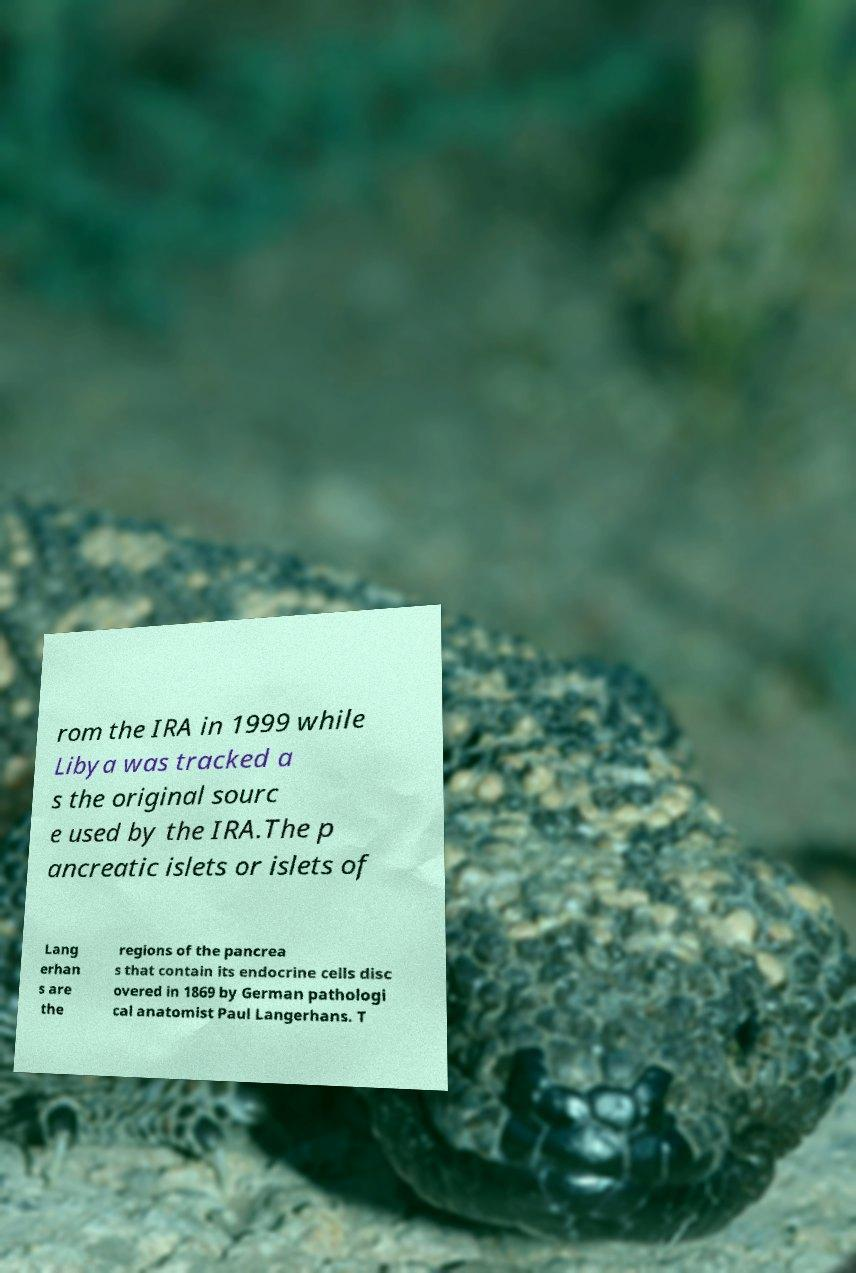For documentation purposes, I need the text within this image transcribed. Could you provide that? rom the IRA in 1999 while Libya was tracked a s the original sourc e used by the IRA.The p ancreatic islets or islets of Lang erhan s are the regions of the pancrea s that contain its endocrine cells disc overed in 1869 by German pathologi cal anatomist Paul Langerhans. T 